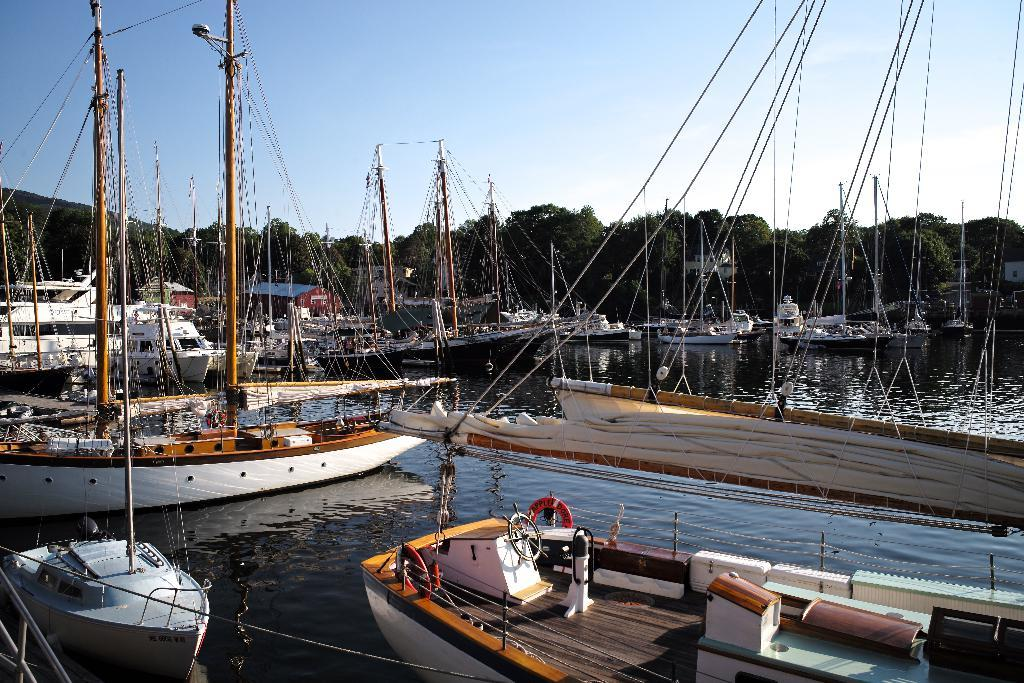What is located in the water in the image? There are ships in the water in the image. What type of structures can be seen in the image? There are houses in the image. What type of vegetation is present in the image? There are trees in the image. What are the poles used for in the image? The poles are likely used for supporting cables in the image. What is visible in the sky in the image? The sky is visible in the image. What type of paste is being used to hold the week together in the image? There is no paste or week present in the image; it features ships in the water, houses, trees, poles, cables, and a visible sky. 